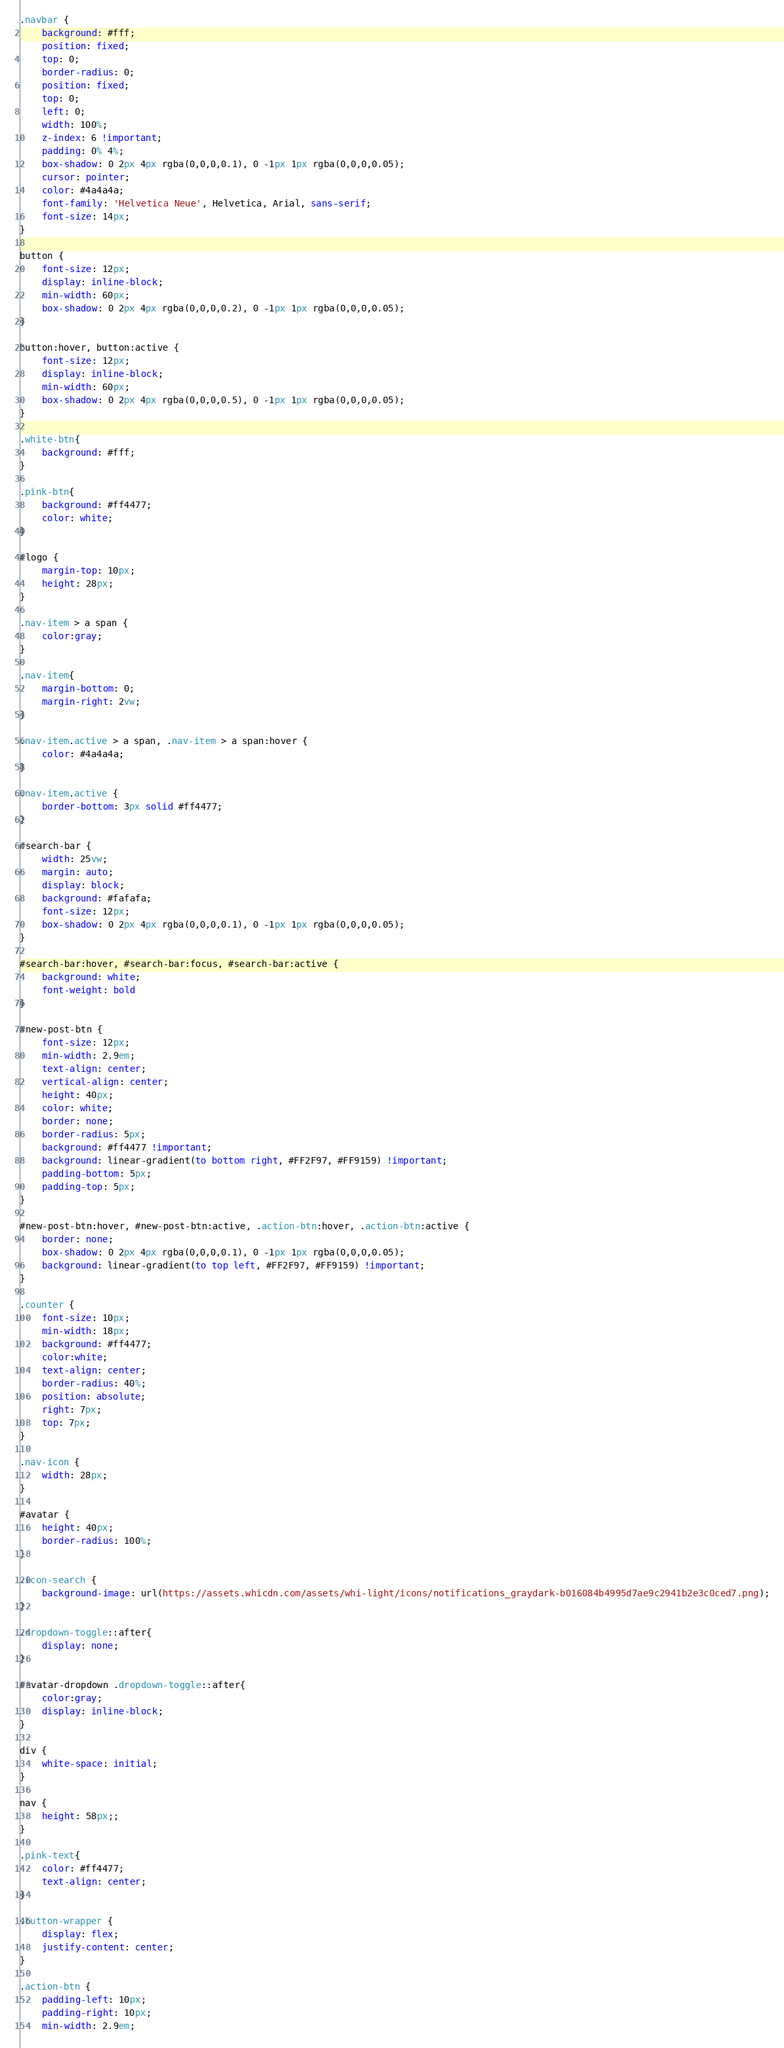<code> <loc_0><loc_0><loc_500><loc_500><_CSS_>.navbar {
    background: #fff;
    position: fixed;
    top: 0;
    border-radius: 0;
    position: fixed;
    top: 0;
    left: 0;
    width: 100%;
    z-index: 6 !important;
    padding: 0% 4%;
    box-shadow: 0 2px 4px rgba(0,0,0,0.1), 0 -1px 1px rgba(0,0,0,0.05);
    cursor: pointer;
    color: #4a4a4a;
    font-family: 'Helvetica Neue', Helvetica, Arial, sans-serif;
    font-size: 14px;
}

button {
    font-size: 12px;
    display: inline-block;
    min-width: 60px;
    box-shadow: 0 2px 4px rgba(0,0,0,0.2), 0 -1px 1px rgba(0,0,0,0.05);
}

button:hover, button:active {
    font-size: 12px;
    display: inline-block;
    min-width: 60px;
    box-shadow: 0 2px 4px rgba(0,0,0,0.5), 0 -1px 1px rgba(0,0,0,0.05);
}

.white-btn{
    background: #fff;
}

.pink-btn{
    background: #ff4477;
    color: white;
}

#logo {
    margin-top: 10px;
    height: 28px;
}

.nav-item > a span {
    color:gray;
}

.nav-item{
    margin-bottom: 0;
    margin-right: 2vw;
}

.nav-item.active > a span, .nav-item > a span:hover {
    color: #4a4a4a;
}

.nav-item.active {
    border-bottom: 3px solid #ff4477;
}

#search-bar {
    width: 25vw;
    margin: auto;
    display: block;
    background: #fafafa;
    font-size: 12px;
    box-shadow: 0 2px 4px rgba(0,0,0,0.1), 0 -1px 1px rgba(0,0,0,0.05);
}

#search-bar:hover, #search-bar:focus, #search-bar:active {
    background: white;
    font-weight: bold
}

#new-post-btn {
    font-size: 12px;
    min-width: 2.9em;
    text-align: center;
    vertical-align: center;
    height: 40px;
    color: white;
    border: none;
    border-radius: 5px;
    background: #ff4477 !important;
    background: linear-gradient(to bottom right, #FF2F97, #FF9159) !important;
    padding-bottom: 5px;
    padding-top: 5px;
}

#new-post-btn:hover, #new-post-btn:active, .action-btn:hover, .action-btn:active {
    border: none;
    box-shadow: 0 2px 4px rgba(0,0,0,0.1), 0 -1px 1px rgba(0,0,0,0.05);
    background: linear-gradient(to top left, #FF2F97, #FF9159) !important;
}

.counter {
    font-size: 10px;
    min-width: 18px;
    background: #ff4477;
    color:white;
    text-align: center;
    border-radius: 40%;
    position: absolute;
    right: 7px;
    top: 7px;
}

.nav-icon {
    width: 28px;
}

#avatar {
    height: 40px;
    border-radius: 100%;
}

.icon-search {
    background-image: url(https://assets.whicdn.com/assets/whi-light/icons/notifications_graydark-b016084b4995d7ae9c2941b2e3c0ced7.png);
}

.dropdown-toggle::after{
    display: none;
}

#avatar-dropdown .dropdown-toggle::after{
    color:gray;
    display: inline-block;
}

div {
    white-space: initial;
}

nav {
    height: 58px;;
}

.pink-text{
    color: #ff4477;
    text-align: center;
}

.button-wrapper {
    display: flex;
    justify-content: center;
}

.action-btn {
    padding-left: 10px;
    padding-right: 10px;
    min-width: 2.9em;</code> 